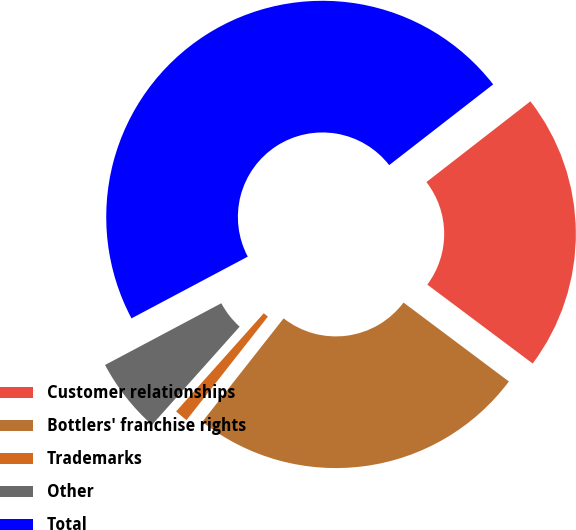Convert chart. <chart><loc_0><loc_0><loc_500><loc_500><pie_chart><fcel>Customer relationships<fcel>Bottlers' franchise rights<fcel>Trademarks<fcel>Other<fcel>Total<nl><fcel>20.74%<fcel>25.37%<fcel>1.0%<fcel>5.63%<fcel>47.26%<nl></chart> 